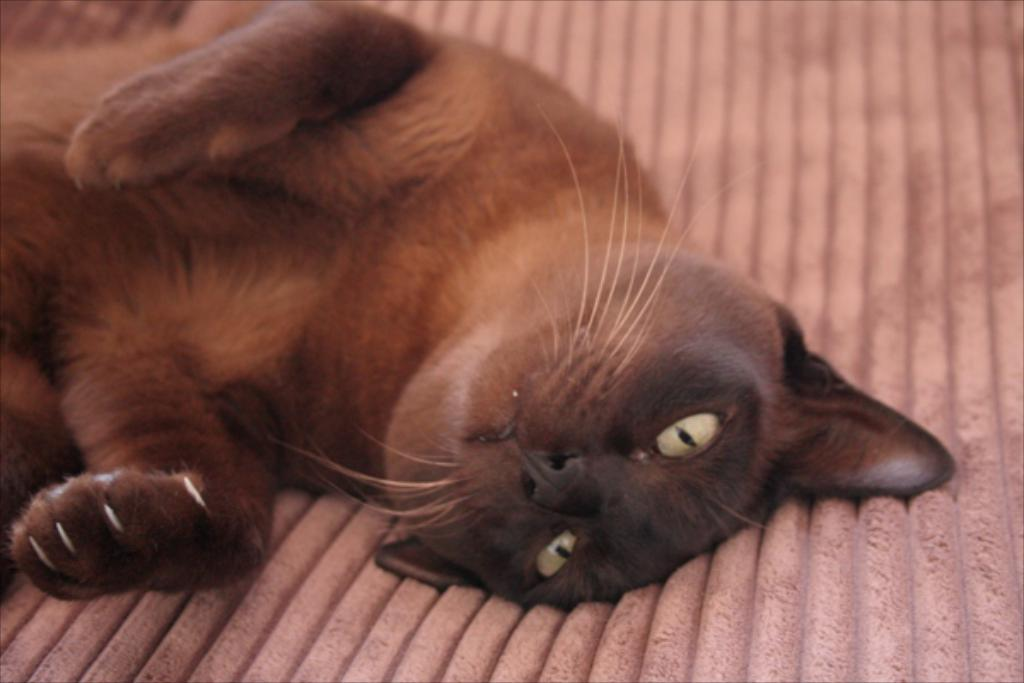What type of animal is in the image? There is a cat in the image. What is the cat doing in the image? The cat is lying on a surface. Can you describe the surface the cat is lying on? The surface looks like a mat. How many baby dinosaurs are playing with the cat on the mat? There are no baby dinosaurs present in the image; it features a cat lying on a mat. 